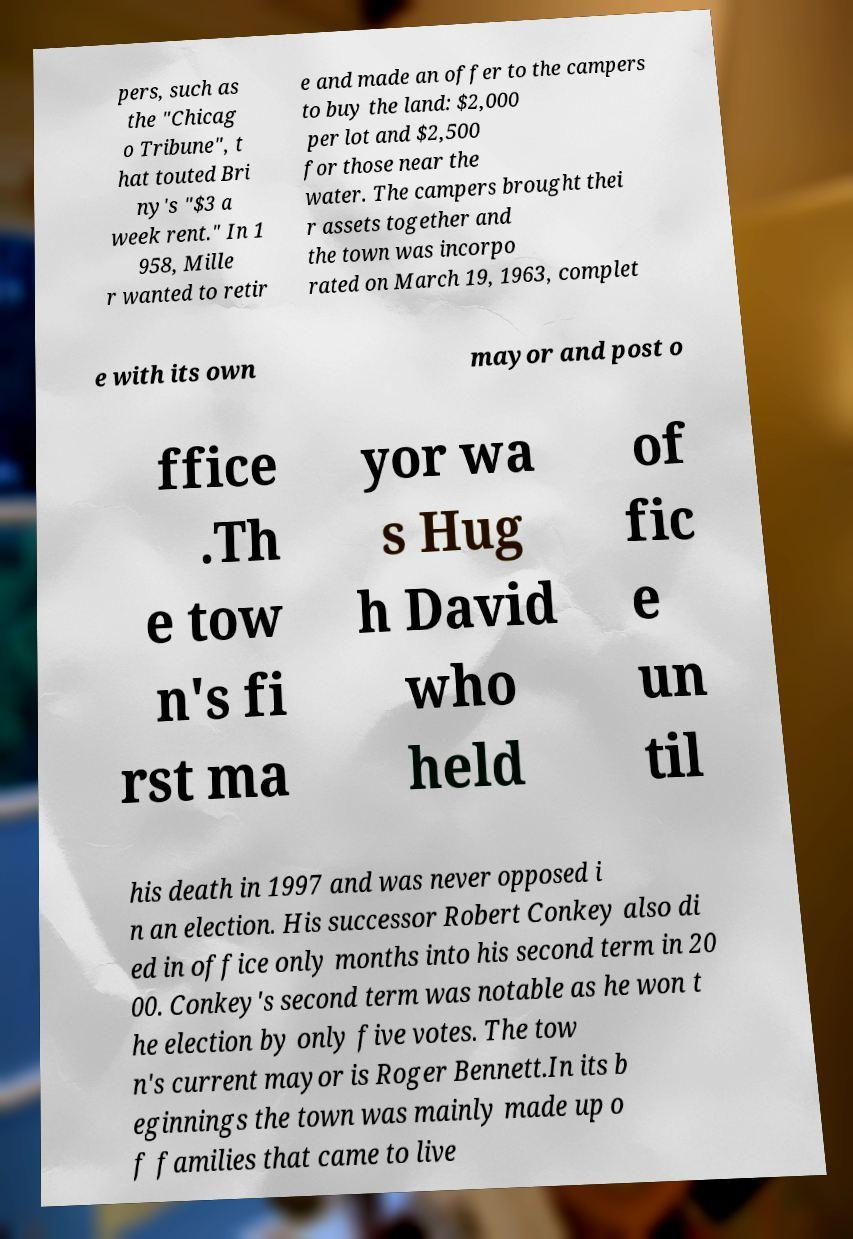Please identify and transcribe the text found in this image. pers, such as the "Chicag o Tribune", t hat touted Bri ny's "$3 a week rent." In 1 958, Mille r wanted to retir e and made an offer to the campers to buy the land: $2,000 per lot and $2,500 for those near the water. The campers brought thei r assets together and the town was incorpo rated on March 19, 1963, complet e with its own mayor and post o ffice .Th e tow n's fi rst ma yor wa s Hug h David who held of fic e un til his death in 1997 and was never opposed i n an election. His successor Robert Conkey also di ed in office only months into his second term in 20 00. Conkey's second term was notable as he won t he election by only five votes. The tow n's current mayor is Roger Bennett.In its b eginnings the town was mainly made up o f families that came to live 